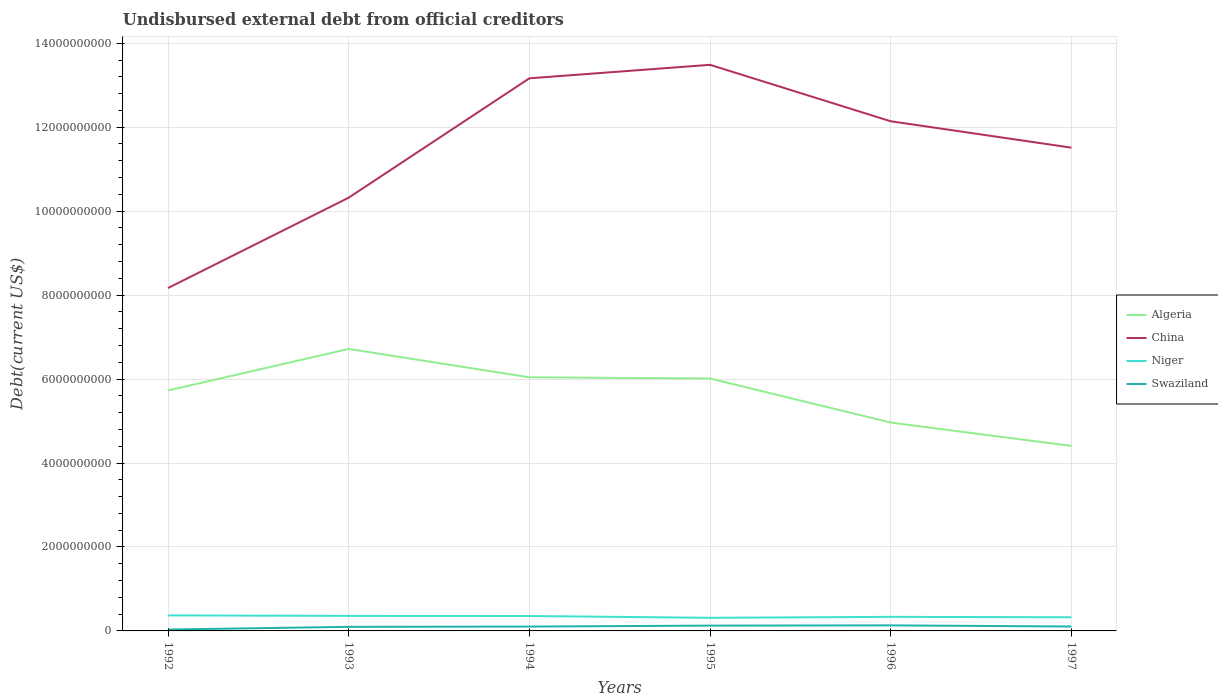How many different coloured lines are there?
Your answer should be compact. 4. Is the number of lines equal to the number of legend labels?
Offer a terse response. Yes. Across all years, what is the maximum total debt in Niger?
Offer a terse response. 3.13e+08. What is the total total debt in Algeria in the graph?
Provide a succinct answer. 2.31e+09. What is the difference between the highest and the second highest total debt in Algeria?
Keep it short and to the point. 2.31e+09. How many years are there in the graph?
Your answer should be compact. 6. Are the values on the major ticks of Y-axis written in scientific E-notation?
Keep it short and to the point. No. How many legend labels are there?
Provide a short and direct response. 4. How are the legend labels stacked?
Ensure brevity in your answer.  Vertical. What is the title of the graph?
Offer a very short reply. Undisbursed external debt from official creditors. Does "East Asia (all income levels)" appear as one of the legend labels in the graph?
Your answer should be compact. No. What is the label or title of the X-axis?
Give a very brief answer. Years. What is the label or title of the Y-axis?
Your response must be concise. Debt(current US$). What is the Debt(current US$) in Algeria in 1992?
Keep it short and to the point. 5.73e+09. What is the Debt(current US$) of China in 1992?
Your answer should be compact. 8.17e+09. What is the Debt(current US$) in Niger in 1992?
Give a very brief answer. 3.70e+08. What is the Debt(current US$) of Swaziland in 1992?
Offer a terse response. 3.31e+07. What is the Debt(current US$) of Algeria in 1993?
Keep it short and to the point. 6.72e+09. What is the Debt(current US$) in China in 1993?
Make the answer very short. 1.03e+1. What is the Debt(current US$) of Niger in 1993?
Provide a short and direct response. 3.58e+08. What is the Debt(current US$) of Swaziland in 1993?
Give a very brief answer. 9.72e+07. What is the Debt(current US$) in Algeria in 1994?
Keep it short and to the point. 6.04e+09. What is the Debt(current US$) of China in 1994?
Ensure brevity in your answer.  1.32e+1. What is the Debt(current US$) of Niger in 1994?
Your response must be concise. 3.55e+08. What is the Debt(current US$) of Swaziland in 1994?
Your answer should be very brief. 1.04e+08. What is the Debt(current US$) of Algeria in 1995?
Your answer should be compact. 6.01e+09. What is the Debt(current US$) of China in 1995?
Your answer should be compact. 1.35e+1. What is the Debt(current US$) of Niger in 1995?
Your answer should be compact. 3.13e+08. What is the Debt(current US$) of Swaziland in 1995?
Offer a terse response. 1.27e+08. What is the Debt(current US$) of Algeria in 1996?
Keep it short and to the point. 4.96e+09. What is the Debt(current US$) of China in 1996?
Offer a terse response. 1.21e+1. What is the Debt(current US$) in Niger in 1996?
Your answer should be very brief. 3.35e+08. What is the Debt(current US$) in Swaziland in 1996?
Provide a succinct answer. 1.32e+08. What is the Debt(current US$) of Algeria in 1997?
Your answer should be very brief. 4.41e+09. What is the Debt(current US$) of China in 1997?
Your answer should be compact. 1.15e+1. What is the Debt(current US$) in Niger in 1997?
Keep it short and to the point. 3.25e+08. What is the Debt(current US$) in Swaziland in 1997?
Your answer should be compact. 1.05e+08. Across all years, what is the maximum Debt(current US$) of Algeria?
Give a very brief answer. 6.72e+09. Across all years, what is the maximum Debt(current US$) of China?
Provide a short and direct response. 1.35e+1. Across all years, what is the maximum Debt(current US$) of Niger?
Provide a short and direct response. 3.70e+08. Across all years, what is the maximum Debt(current US$) of Swaziland?
Provide a succinct answer. 1.32e+08. Across all years, what is the minimum Debt(current US$) of Algeria?
Offer a terse response. 4.41e+09. Across all years, what is the minimum Debt(current US$) in China?
Provide a succinct answer. 8.17e+09. Across all years, what is the minimum Debt(current US$) in Niger?
Ensure brevity in your answer.  3.13e+08. Across all years, what is the minimum Debt(current US$) of Swaziland?
Your response must be concise. 3.31e+07. What is the total Debt(current US$) of Algeria in the graph?
Make the answer very short. 3.39e+1. What is the total Debt(current US$) in China in the graph?
Keep it short and to the point. 6.88e+1. What is the total Debt(current US$) in Niger in the graph?
Keep it short and to the point. 2.06e+09. What is the total Debt(current US$) in Swaziland in the graph?
Offer a terse response. 5.98e+08. What is the difference between the Debt(current US$) in Algeria in 1992 and that in 1993?
Give a very brief answer. -9.90e+08. What is the difference between the Debt(current US$) of China in 1992 and that in 1993?
Ensure brevity in your answer.  -2.15e+09. What is the difference between the Debt(current US$) in Niger in 1992 and that in 1993?
Your answer should be compact. 1.20e+07. What is the difference between the Debt(current US$) in Swaziland in 1992 and that in 1993?
Your answer should be compact. -6.41e+07. What is the difference between the Debt(current US$) of Algeria in 1992 and that in 1994?
Give a very brief answer. -3.14e+08. What is the difference between the Debt(current US$) in China in 1992 and that in 1994?
Your answer should be very brief. -5.00e+09. What is the difference between the Debt(current US$) of Niger in 1992 and that in 1994?
Your response must be concise. 1.50e+07. What is the difference between the Debt(current US$) of Swaziland in 1992 and that in 1994?
Keep it short and to the point. -7.07e+07. What is the difference between the Debt(current US$) of Algeria in 1992 and that in 1995?
Provide a succinct answer. -2.85e+08. What is the difference between the Debt(current US$) of China in 1992 and that in 1995?
Make the answer very short. -5.32e+09. What is the difference between the Debt(current US$) of Niger in 1992 and that in 1995?
Provide a succinct answer. 5.73e+07. What is the difference between the Debt(current US$) in Swaziland in 1992 and that in 1995?
Offer a terse response. -9.35e+07. What is the difference between the Debt(current US$) of Algeria in 1992 and that in 1996?
Ensure brevity in your answer.  7.64e+08. What is the difference between the Debt(current US$) of China in 1992 and that in 1996?
Provide a succinct answer. -3.97e+09. What is the difference between the Debt(current US$) in Niger in 1992 and that in 1996?
Your answer should be compact. 3.53e+07. What is the difference between the Debt(current US$) of Swaziland in 1992 and that in 1996?
Ensure brevity in your answer.  -9.93e+07. What is the difference between the Debt(current US$) in Algeria in 1992 and that in 1997?
Keep it short and to the point. 1.32e+09. What is the difference between the Debt(current US$) in China in 1992 and that in 1997?
Give a very brief answer. -3.34e+09. What is the difference between the Debt(current US$) of Niger in 1992 and that in 1997?
Make the answer very short. 4.50e+07. What is the difference between the Debt(current US$) in Swaziland in 1992 and that in 1997?
Provide a short and direct response. -7.18e+07. What is the difference between the Debt(current US$) of Algeria in 1993 and that in 1994?
Your response must be concise. 6.76e+08. What is the difference between the Debt(current US$) in China in 1993 and that in 1994?
Your response must be concise. -2.84e+09. What is the difference between the Debt(current US$) of Niger in 1993 and that in 1994?
Offer a terse response. 3.01e+06. What is the difference between the Debt(current US$) in Swaziland in 1993 and that in 1994?
Your response must be concise. -6.55e+06. What is the difference between the Debt(current US$) in Algeria in 1993 and that in 1995?
Ensure brevity in your answer.  7.04e+08. What is the difference between the Debt(current US$) in China in 1993 and that in 1995?
Ensure brevity in your answer.  -3.16e+09. What is the difference between the Debt(current US$) in Niger in 1993 and that in 1995?
Make the answer very short. 4.54e+07. What is the difference between the Debt(current US$) of Swaziland in 1993 and that in 1995?
Offer a very short reply. -2.94e+07. What is the difference between the Debt(current US$) of Algeria in 1993 and that in 1996?
Give a very brief answer. 1.75e+09. What is the difference between the Debt(current US$) of China in 1993 and that in 1996?
Ensure brevity in your answer.  -1.82e+09. What is the difference between the Debt(current US$) of Niger in 1993 and that in 1996?
Provide a succinct answer. 2.34e+07. What is the difference between the Debt(current US$) in Swaziland in 1993 and that in 1996?
Provide a short and direct response. -3.51e+07. What is the difference between the Debt(current US$) of Algeria in 1993 and that in 1997?
Provide a short and direct response. 2.31e+09. What is the difference between the Debt(current US$) in China in 1993 and that in 1997?
Your answer should be compact. -1.19e+09. What is the difference between the Debt(current US$) of Niger in 1993 and that in 1997?
Offer a very short reply. 3.31e+07. What is the difference between the Debt(current US$) in Swaziland in 1993 and that in 1997?
Offer a very short reply. -7.65e+06. What is the difference between the Debt(current US$) in Algeria in 1994 and that in 1995?
Give a very brief answer. 2.85e+07. What is the difference between the Debt(current US$) in China in 1994 and that in 1995?
Keep it short and to the point. -3.22e+08. What is the difference between the Debt(current US$) of Niger in 1994 and that in 1995?
Your answer should be compact. 4.24e+07. What is the difference between the Debt(current US$) of Swaziland in 1994 and that in 1995?
Your answer should be very brief. -2.28e+07. What is the difference between the Debt(current US$) of Algeria in 1994 and that in 1996?
Ensure brevity in your answer.  1.08e+09. What is the difference between the Debt(current US$) in China in 1994 and that in 1996?
Offer a very short reply. 1.02e+09. What is the difference between the Debt(current US$) in Niger in 1994 and that in 1996?
Keep it short and to the point. 2.03e+07. What is the difference between the Debt(current US$) in Swaziland in 1994 and that in 1996?
Make the answer very short. -2.86e+07. What is the difference between the Debt(current US$) of Algeria in 1994 and that in 1997?
Offer a very short reply. 1.63e+09. What is the difference between the Debt(current US$) in China in 1994 and that in 1997?
Offer a terse response. 1.65e+09. What is the difference between the Debt(current US$) of Niger in 1994 and that in 1997?
Make the answer very short. 3.01e+07. What is the difference between the Debt(current US$) of Swaziland in 1994 and that in 1997?
Ensure brevity in your answer.  -1.10e+06. What is the difference between the Debt(current US$) in Algeria in 1995 and that in 1996?
Ensure brevity in your answer.  1.05e+09. What is the difference between the Debt(current US$) in China in 1995 and that in 1996?
Your response must be concise. 1.34e+09. What is the difference between the Debt(current US$) of Niger in 1995 and that in 1996?
Ensure brevity in your answer.  -2.20e+07. What is the difference between the Debt(current US$) in Swaziland in 1995 and that in 1996?
Give a very brief answer. -5.76e+06. What is the difference between the Debt(current US$) of Algeria in 1995 and that in 1997?
Ensure brevity in your answer.  1.61e+09. What is the difference between the Debt(current US$) of China in 1995 and that in 1997?
Keep it short and to the point. 1.97e+09. What is the difference between the Debt(current US$) in Niger in 1995 and that in 1997?
Give a very brief answer. -1.23e+07. What is the difference between the Debt(current US$) in Swaziland in 1995 and that in 1997?
Make the answer very short. 2.17e+07. What is the difference between the Debt(current US$) in Algeria in 1996 and that in 1997?
Your answer should be very brief. 5.57e+08. What is the difference between the Debt(current US$) in China in 1996 and that in 1997?
Offer a terse response. 6.29e+08. What is the difference between the Debt(current US$) in Niger in 1996 and that in 1997?
Offer a terse response. 9.73e+06. What is the difference between the Debt(current US$) of Swaziland in 1996 and that in 1997?
Your answer should be very brief. 2.75e+07. What is the difference between the Debt(current US$) of Algeria in 1992 and the Debt(current US$) of China in 1993?
Offer a terse response. -4.59e+09. What is the difference between the Debt(current US$) of Algeria in 1992 and the Debt(current US$) of Niger in 1993?
Keep it short and to the point. 5.37e+09. What is the difference between the Debt(current US$) of Algeria in 1992 and the Debt(current US$) of Swaziland in 1993?
Your response must be concise. 5.63e+09. What is the difference between the Debt(current US$) in China in 1992 and the Debt(current US$) in Niger in 1993?
Provide a short and direct response. 7.81e+09. What is the difference between the Debt(current US$) in China in 1992 and the Debt(current US$) in Swaziland in 1993?
Your answer should be very brief. 8.07e+09. What is the difference between the Debt(current US$) of Niger in 1992 and the Debt(current US$) of Swaziland in 1993?
Give a very brief answer. 2.73e+08. What is the difference between the Debt(current US$) of Algeria in 1992 and the Debt(current US$) of China in 1994?
Provide a short and direct response. -7.44e+09. What is the difference between the Debt(current US$) in Algeria in 1992 and the Debt(current US$) in Niger in 1994?
Give a very brief answer. 5.37e+09. What is the difference between the Debt(current US$) of Algeria in 1992 and the Debt(current US$) of Swaziland in 1994?
Your answer should be compact. 5.62e+09. What is the difference between the Debt(current US$) of China in 1992 and the Debt(current US$) of Niger in 1994?
Your response must be concise. 7.81e+09. What is the difference between the Debt(current US$) in China in 1992 and the Debt(current US$) in Swaziland in 1994?
Offer a very short reply. 8.06e+09. What is the difference between the Debt(current US$) in Niger in 1992 and the Debt(current US$) in Swaziland in 1994?
Make the answer very short. 2.66e+08. What is the difference between the Debt(current US$) in Algeria in 1992 and the Debt(current US$) in China in 1995?
Ensure brevity in your answer.  -7.76e+09. What is the difference between the Debt(current US$) of Algeria in 1992 and the Debt(current US$) of Niger in 1995?
Your response must be concise. 5.41e+09. What is the difference between the Debt(current US$) in Algeria in 1992 and the Debt(current US$) in Swaziland in 1995?
Make the answer very short. 5.60e+09. What is the difference between the Debt(current US$) in China in 1992 and the Debt(current US$) in Niger in 1995?
Your answer should be very brief. 7.86e+09. What is the difference between the Debt(current US$) in China in 1992 and the Debt(current US$) in Swaziland in 1995?
Give a very brief answer. 8.04e+09. What is the difference between the Debt(current US$) in Niger in 1992 and the Debt(current US$) in Swaziland in 1995?
Offer a very short reply. 2.44e+08. What is the difference between the Debt(current US$) of Algeria in 1992 and the Debt(current US$) of China in 1996?
Provide a short and direct response. -6.41e+09. What is the difference between the Debt(current US$) in Algeria in 1992 and the Debt(current US$) in Niger in 1996?
Offer a very short reply. 5.39e+09. What is the difference between the Debt(current US$) of Algeria in 1992 and the Debt(current US$) of Swaziland in 1996?
Offer a terse response. 5.60e+09. What is the difference between the Debt(current US$) in China in 1992 and the Debt(current US$) in Niger in 1996?
Give a very brief answer. 7.83e+09. What is the difference between the Debt(current US$) of China in 1992 and the Debt(current US$) of Swaziland in 1996?
Ensure brevity in your answer.  8.04e+09. What is the difference between the Debt(current US$) of Niger in 1992 and the Debt(current US$) of Swaziland in 1996?
Provide a succinct answer. 2.38e+08. What is the difference between the Debt(current US$) of Algeria in 1992 and the Debt(current US$) of China in 1997?
Provide a short and direct response. -5.78e+09. What is the difference between the Debt(current US$) in Algeria in 1992 and the Debt(current US$) in Niger in 1997?
Provide a succinct answer. 5.40e+09. What is the difference between the Debt(current US$) of Algeria in 1992 and the Debt(current US$) of Swaziland in 1997?
Your answer should be very brief. 5.62e+09. What is the difference between the Debt(current US$) in China in 1992 and the Debt(current US$) in Niger in 1997?
Offer a very short reply. 7.84e+09. What is the difference between the Debt(current US$) in China in 1992 and the Debt(current US$) in Swaziland in 1997?
Keep it short and to the point. 8.06e+09. What is the difference between the Debt(current US$) in Niger in 1992 and the Debt(current US$) in Swaziland in 1997?
Your answer should be very brief. 2.65e+08. What is the difference between the Debt(current US$) of Algeria in 1993 and the Debt(current US$) of China in 1994?
Offer a very short reply. -6.45e+09. What is the difference between the Debt(current US$) in Algeria in 1993 and the Debt(current US$) in Niger in 1994?
Provide a succinct answer. 6.36e+09. What is the difference between the Debt(current US$) of Algeria in 1993 and the Debt(current US$) of Swaziland in 1994?
Ensure brevity in your answer.  6.61e+09. What is the difference between the Debt(current US$) of China in 1993 and the Debt(current US$) of Niger in 1994?
Keep it short and to the point. 9.97e+09. What is the difference between the Debt(current US$) of China in 1993 and the Debt(current US$) of Swaziland in 1994?
Provide a short and direct response. 1.02e+1. What is the difference between the Debt(current US$) in Niger in 1993 and the Debt(current US$) in Swaziland in 1994?
Make the answer very short. 2.54e+08. What is the difference between the Debt(current US$) in Algeria in 1993 and the Debt(current US$) in China in 1995?
Your response must be concise. -6.77e+09. What is the difference between the Debt(current US$) in Algeria in 1993 and the Debt(current US$) in Niger in 1995?
Provide a succinct answer. 6.40e+09. What is the difference between the Debt(current US$) in Algeria in 1993 and the Debt(current US$) in Swaziland in 1995?
Keep it short and to the point. 6.59e+09. What is the difference between the Debt(current US$) in China in 1993 and the Debt(current US$) in Niger in 1995?
Ensure brevity in your answer.  1.00e+1. What is the difference between the Debt(current US$) in China in 1993 and the Debt(current US$) in Swaziland in 1995?
Your answer should be compact. 1.02e+1. What is the difference between the Debt(current US$) of Niger in 1993 and the Debt(current US$) of Swaziland in 1995?
Provide a succinct answer. 2.32e+08. What is the difference between the Debt(current US$) in Algeria in 1993 and the Debt(current US$) in China in 1996?
Make the answer very short. -5.42e+09. What is the difference between the Debt(current US$) in Algeria in 1993 and the Debt(current US$) in Niger in 1996?
Provide a short and direct response. 6.38e+09. What is the difference between the Debt(current US$) in Algeria in 1993 and the Debt(current US$) in Swaziland in 1996?
Keep it short and to the point. 6.58e+09. What is the difference between the Debt(current US$) of China in 1993 and the Debt(current US$) of Niger in 1996?
Provide a succinct answer. 9.99e+09. What is the difference between the Debt(current US$) of China in 1993 and the Debt(current US$) of Swaziland in 1996?
Give a very brief answer. 1.02e+1. What is the difference between the Debt(current US$) of Niger in 1993 and the Debt(current US$) of Swaziland in 1996?
Provide a succinct answer. 2.26e+08. What is the difference between the Debt(current US$) of Algeria in 1993 and the Debt(current US$) of China in 1997?
Your response must be concise. -4.79e+09. What is the difference between the Debt(current US$) of Algeria in 1993 and the Debt(current US$) of Niger in 1997?
Give a very brief answer. 6.39e+09. What is the difference between the Debt(current US$) of Algeria in 1993 and the Debt(current US$) of Swaziland in 1997?
Offer a very short reply. 6.61e+09. What is the difference between the Debt(current US$) in China in 1993 and the Debt(current US$) in Niger in 1997?
Offer a very short reply. 1.00e+1. What is the difference between the Debt(current US$) in China in 1993 and the Debt(current US$) in Swaziland in 1997?
Make the answer very short. 1.02e+1. What is the difference between the Debt(current US$) in Niger in 1993 and the Debt(current US$) in Swaziland in 1997?
Keep it short and to the point. 2.53e+08. What is the difference between the Debt(current US$) of Algeria in 1994 and the Debt(current US$) of China in 1995?
Make the answer very short. -7.44e+09. What is the difference between the Debt(current US$) in Algeria in 1994 and the Debt(current US$) in Niger in 1995?
Your response must be concise. 5.73e+09. What is the difference between the Debt(current US$) in Algeria in 1994 and the Debt(current US$) in Swaziland in 1995?
Your answer should be compact. 5.91e+09. What is the difference between the Debt(current US$) in China in 1994 and the Debt(current US$) in Niger in 1995?
Your answer should be very brief. 1.29e+1. What is the difference between the Debt(current US$) in China in 1994 and the Debt(current US$) in Swaziland in 1995?
Your response must be concise. 1.30e+1. What is the difference between the Debt(current US$) of Niger in 1994 and the Debt(current US$) of Swaziland in 1995?
Your answer should be very brief. 2.29e+08. What is the difference between the Debt(current US$) in Algeria in 1994 and the Debt(current US$) in China in 1996?
Offer a very short reply. -6.10e+09. What is the difference between the Debt(current US$) of Algeria in 1994 and the Debt(current US$) of Niger in 1996?
Provide a succinct answer. 5.71e+09. What is the difference between the Debt(current US$) of Algeria in 1994 and the Debt(current US$) of Swaziland in 1996?
Keep it short and to the point. 5.91e+09. What is the difference between the Debt(current US$) in China in 1994 and the Debt(current US$) in Niger in 1996?
Make the answer very short. 1.28e+1. What is the difference between the Debt(current US$) of China in 1994 and the Debt(current US$) of Swaziland in 1996?
Offer a very short reply. 1.30e+1. What is the difference between the Debt(current US$) in Niger in 1994 and the Debt(current US$) in Swaziland in 1996?
Provide a short and direct response. 2.23e+08. What is the difference between the Debt(current US$) of Algeria in 1994 and the Debt(current US$) of China in 1997?
Your answer should be very brief. -5.47e+09. What is the difference between the Debt(current US$) in Algeria in 1994 and the Debt(current US$) in Niger in 1997?
Offer a very short reply. 5.72e+09. What is the difference between the Debt(current US$) in Algeria in 1994 and the Debt(current US$) in Swaziland in 1997?
Provide a short and direct response. 5.94e+09. What is the difference between the Debt(current US$) in China in 1994 and the Debt(current US$) in Niger in 1997?
Make the answer very short. 1.28e+1. What is the difference between the Debt(current US$) in China in 1994 and the Debt(current US$) in Swaziland in 1997?
Provide a short and direct response. 1.31e+1. What is the difference between the Debt(current US$) in Niger in 1994 and the Debt(current US$) in Swaziland in 1997?
Provide a succinct answer. 2.50e+08. What is the difference between the Debt(current US$) in Algeria in 1995 and the Debt(current US$) in China in 1996?
Your answer should be compact. -6.13e+09. What is the difference between the Debt(current US$) of Algeria in 1995 and the Debt(current US$) of Niger in 1996?
Provide a succinct answer. 5.68e+09. What is the difference between the Debt(current US$) of Algeria in 1995 and the Debt(current US$) of Swaziland in 1996?
Keep it short and to the point. 5.88e+09. What is the difference between the Debt(current US$) in China in 1995 and the Debt(current US$) in Niger in 1996?
Your answer should be very brief. 1.32e+1. What is the difference between the Debt(current US$) of China in 1995 and the Debt(current US$) of Swaziland in 1996?
Keep it short and to the point. 1.34e+1. What is the difference between the Debt(current US$) of Niger in 1995 and the Debt(current US$) of Swaziland in 1996?
Offer a terse response. 1.80e+08. What is the difference between the Debt(current US$) in Algeria in 1995 and the Debt(current US$) in China in 1997?
Provide a succinct answer. -5.50e+09. What is the difference between the Debt(current US$) in Algeria in 1995 and the Debt(current US$) in Niger in 1997?
Offer a terse response. 5.69e+09. What is the difference between the Debt(current US$) in Algeria in 1995 and the Debt(current US$) in Swaziland in 1997?
Provide a succinct answer. 5.91e+09. What is the difference between the Debt(current US$) in China in 1995 and the Debt(current US$) in Niger in 1997?
Offer a terse response. 1.32e+1. What is the difference between the Debt(current US$) of China in 1995 and the Debt(current US$) of Swaziland in 1997?
Your response must be concise. 1.34e+1. What is the difference between the Debt(current US$) of Niger in 1995 and the Debt(current US$) of Swaziland in 1997?
Give a very brief answer. 2.08e+08. What is the difference between the Debt(current US$) in Algeria in 1996 and the Debt(current US$) in China in 1997?
Provide a succinct answer. -6.55e+09. What is the difference between the Debt(current US$) in Algeria in 1996 and the Debt(current US$) in Niger in 1997?
Your response must be concise. 4.64e+09. What is the difference between the Debt(current US$) in Algeria in 1996 and the Debt(current US$) in Swaziland in 1997?
Keep it short and to the point. 4.86e+09. What is the difference between the Debt(current US$) of China in 1996 and the Debt(current US$) of Niger in 1997?
Your response must be concise. 1.18e+1. What is the difference between the Debt(current US$) in China in 1996 and the Debt(current US$) in Swaziland in 1997?
Offer a very short reply. 1.20e+1. What is the difference between the Debt(current US$) in Niger in 1996 and the Debt(current US$) in Swaziland in 1997?
Give a very brief answer. 2.30e+08. What is the average Debt(current US$) of Algeria per year?
Ensure brevity in your answer.  5.65e+09. What is the average Debt(current US$) of China per year?
Provide a succinct answer. 1.15e+1. What is the average Debt(current US$) of Niger per year?
Provide a succinct answer. 3.43e+08. What is the average Debt(current US$) in Swaziland per year?
Your response must be concise. 9.97e+07. In the year 1992, what is the difference between the Debt(current US$) in Algeria and Debt(current US$) in China?
Provide a succinct answer. -2.44e+09. In the year 1992, what is the difference between the Debt(current US$) in Algeria and Debt(current US$) in Niger?
Keep it short and to the point. 5.36e+09. In the year 1992, what is the difference between the Debt(current US$) of Algeria and Debt(current US$) of Swaziland?
Your response must be concise. 5.69e+09. In the year 1992, what is the difference between the Debt(current US$) of China and Debt(current US$) of Niger?
Provide a succinct answer. 7.80e+09. In the year 1992, what is the difference between the Debt(current US$) in China and Debt(current US$) in Swaziland?
Make the answer very short. 8.14e+09. In the year 1992, what is the difference between the Debt(current US$) of Niger and Debt(current US$) of Swaziland?
Offer a very short reply. 3.37e+08. In the year 1993, what is the difference between the Debt(current US$) in Algeria and Debt(current US$) in China?
Offer a very short reply. -3.60e+09. In the year 1993, what is the difference between the Debt(current US$) in Algeria and Debt(current US$) in Niger?
Offer a terse response. 6.36e+09. In the year 1993, what is the difference between the Debt(current US$) of Algeria and Debt(current US$) of Swaziland?
Make the answer very short. 6.62e+09. In the year 1993, what is the difference between the Debt(current US$) of China and Debt(current US$) of Niger?
Offer a terse response. 9.96e+09. In the year 1993, what is the difference between the Debt(current US$) of China and Debt(current US$) of Swaziland?
Ensure brevity in your answer.  1.02e+1. In the year 1993, what is the difference between the Debt(current US$) in Niger and Debt(current US$) in Swaziland?
Give a very brief answer. 2.61e+08. In the year 1994, what is the difference between the Debt(current US$) of Algeria and Debt(current US$) of China?
Ensure brevity in your answer.  -7.12e+09. In the year 1994, what is the difference between the Debt(current US$) of Algeria and Debt(current US$) of Niger?
Keep it short and to the point. 5.69e+09. In the year 1994, what is the difference between the Debt(current US$) in Algeria and Debt(current US$) in Swaziland?
Keep it short and to the point. 5.94e+09. In the year 1994, what is the difference between the Debt(current US$) in China and Debt(current US$) in Niger?
Offer a terse response. 1.28e+1. In the year 1994, what is the difference between the Debt(current US$) in China and Debt(current US$) in Swaziland?
Your answer should be compact. 1.31e+1. In the year 1994, what is the difference between the Debt(current US$) in Niger and Debt(current US$) in Swaziland?
Offer a terse response. 2.51e+08. In the year 1995, what is the difference between the Debt(current US$) of Algeria and Debt(current US$) of China?
Keep it short and to the point. -7.47e+09. In the year 1995, what is the difference between the Debt(current US$) in Algeria and Debt(current US$) in Niger?
Keep it short and to the point. 5.70e+09. In the year 1995, what is the difference between the Debt(current US$) in Algeria and Debt(current US$) in Swaziland?
Your answer should be compact. 5.89e+09. In the year 1995, what is the difference between the Debt(current US$) of China and Debt(current US$) of Niger?
Make the answer very short. 1.32e+1. In the year 1995, what is the difference between the Debt(current US$) in China and Debt(current US$) in Swaziland?
Give a very brief answer. 1.34e+1. In the year 1995, what is the difference between the Debt(current US$) in Niger and Debt(current US$) in Swaziland?
Keep it short and to the point. 1.86e+08. In the year 1996, what is the difference between the Debt(current US$) of Algeria and Debt(current US$) of China?
Your response must be concise. -7.18e+09. In the year 1996, what is the difference between the Debt(current US$) of Algeria and Debt(current US$) of Niger?
Your answer should be compact. 4.63e+09. In the year 1996, what is the difference between the Debt(current US$) of Algeria and Debt(current US$) of Swaziland?
Ensure brevity in your answer.  4.83e+09. In the year 1996, what is the difference between the Debt(current US$) of China and Debt(current US$) of Niger?
Your response must be concise. 1.18e+1. In the year 1996, what is the difference between the Debt(current US$) of China and Debt(current US$) of Swaziland?
Your answer should be compact. 1.20e+1. In the year 1996, what is the difference between the Debt(current US$) of Niger and Debt(current US$) of Swaziland?
Provide a short and direct response. 2.02e+08. In the year 1997, what is the difference between the Debt(current US$) in Algeria and Debt(current US$) in China?
Offer a very short reply. -7.11e+09. In the year 1997, what is the difference between the Debt(current US$) in Algeria and Debt(current US$) in Niger?
Provide a short and direct response. 4.08e+09. In the year 1997, what is the difference between the Debt(current US$) in Algeria and Debt(current US$) in Swaziland?
Your response must be concise. 4.30e+09. In the year 1997, what is the difference between the Debt(current US$) in China and Debt(current US$) in Niger?
Offer a terse response. 1.12e+1. In the year 1997, what is the difference between the Debt(current US$) of China and Debt(current US$) of Swaziland?
Keep it short and to the point. 1.14e+1. In the year 1997, what is the difference between the Debt(current US$) in Niger and Debt(current US$) in Swaziland?
Your response must be concise. 2.20e+08. What is the ratio of the Debt(current US$) of Algeria in 1992 to that in 1993?
Offer a very short reply. 0.85. What is the ratio of the Debt(current US$) in China in 1992 to that in 1993?
Keep it short and to the point. 0.79. What is the ratio of the Debt(current US$) in Niger in 1992 to that in 1993?
Your response must be concise. 1.03. What is the ratio of the Debt(current US$) in Swaziland in 1992 to that in 1993?
Your answer should be compact. 0.34. What is the ratio of the Debt(current US$) in Algeria in 1992 to that in 1994?
Provide a succinct answer. 0.95. What is the ratio of the Debt(current US$) in China in 1992 to that in 1994?
Ensure brevity in your answer.  0.62. What is the ratio of the Debt(current US$) of Niger in 1992 to that in 1994?
Provide a succinct answer. 1.04. What is the ratio of the Debt(current US$) of Swaziland in 1992 to that in 1994?
Offer a very short reply. 0.32. What is the ratio of the Debt(current US$) in Algeria in 1992 to that in 1995?
Your response must be concise. 0.95. What is the ratio of the Debt(current US$) of China in 1992 to that in 1995?
Your answer should be compact. 0.61. What is the ratio of the Debt(current US$) in Niger in 1992 to that in 1995?
Make the answer very short. 1.18. What is the ratio of the Debt(current US$) of Swaziland in 1992 to that in 1995?
Make the answer very short. 0.26. What is the ratio of the Debt(current US$) of Algeria in 1992 to that in 1996?
Offer a terse response. 1.15. What is the ratio of the Debt(current US$) of China in 1992 to that in 1996?
Your answer should be very brief. 0.67. What is the ratio of the Debt(current US$) in Niger in 1992 to that in 1996?
Provide a succinct answer. 1.11. What is the ratio of the Debt(current US$) in Swaziland in 1992 to that in 1996?
Make the answer very short. 0.25. What is the ratio of the Debt(current US$) in Algeria in 1992 to that in 1997?
Ensure brevity in your answer.  1.3. What is the ratio of the Debt(current US$) in China in 1992 to that in 1997?
Offer a terse response. 0.71. What is the ratio of the Debt(current US$) of Niger in 1992 to that in 1997?
Provide a succinct answer. 1.14. What is the ratio of the Debt(current US$) in Swaziland in 1992 to that in 1997?
Keep it short and to the point. 0.32. What is the ratio of the Debt(current US$) in Algeria in 1993 to that in 1994?
Make the answer very short. 1.11. What is the ratio of the Debt(current US$) in China in 1993 to that in 1994?
Provide a short and direct response. 0.78. What is the ratio of the Debt(current US$) of Niger in 1993 to that in 1994?
Provide a short and direct response. 1.01. What is the ratio of the Debt(current US$) of Swaziland in 1993 to that in 1994?
Make the answer very short. 0.94. What is the ratio of the Debt(current US$) of Algeria in 1993 to that in 1995?
Your answer should be compact. 1.12. What is the ratio of the Debt(current US$) in China in 1993 to that in 1995?
Ensure brevity in your answer.  0.77. What is the ratio of the Debt(current US$) in Niger in 1993 to that in 1995?
Keep it short and to the point. 1.15. What is the ratio of the Debt(current US$) of Swaziland in 1993 to that in 1995?
Your answer should be very brief. 0.77. What is the ratio of the Debt(current US$) of Algeria in 1993 to that in 1996?
Your answer should be very brief. 1.35. What is the ratio of the Debt(current US$) in China in 1993 to that in 1996?
Give a very brief answer. 0.85. What is the ratio of the Debt(current US$) in Niger in 1993 to that in 1996?
Ensure brevity in your answer.  1.07. What is the ratio of the Debt(current US$) in Swaziland in 1993 to that in 1996?
Ensure brevity in your answer.  0.73. What is the ratio of the Debt(current US$) of Algeria in 1993 to that in 1997?
Provide a short and direct response. 1.52. What is the ratio of the Debt(current US$) of China in 1993 to that in 1997?
Your answer should be compact. 0.9. What is the ratio of the Debt(current US$) of Niger in 1993 to that in 1997?
Your answer should be compact. 1.1. What is the ratio of the Debt(current US$) of Swaziland in 1993 to that in 1997?
Your answer should be very brief. 0.93. What is the ratio of the Debt(current US$) of China in 1994 to that in 1995?
Ensure brevity in your answer.  0.98. What is the ratio of the Debt(current US$) in Niger in 1994 to that in 1995?
Make the answer very short. 1.14. What is the ratio of the Debt(current US$) in Swaziland in 1994 to that in 1995?
Provide a succinct answer. 0.82. What is the ratio of the Debt(current US$) of Algeria in 1994 to that in 1996?
Your answer should be very brief. 1.22. What is the ratio of the Debt(current US$) of China in 1994 to that in 1996?
Keep it short and to the point. 1.08. What is the ratio of the Debt(current US$) in Niger in 1994 to that in 1996?
Keep it short and to the point. 1.06. What is the ratio of the Debt(current US$) of Swaziland in 1994 to that in 1996?
Your answer should be compact. 0.78. What is the ratio of the Debt(current US$) in Algeria in 1994 to that in 1997?
Provide a short and direct response. 1.37. What is the ratio of the Debt(current US$) of China in 1994 to that in 1997?
Make the answer very short. 1.14. What is the ratio of the Debt(current US$) in Niger in 1994 to that in 1997?
Provide a succinct answer. 1.09. What is the ratio of the Debt(current US$) of Algeria in 1995 to that in 1996?
Provide a short and direct response. 1.21. What is the ratio of the Debt(current US$) in China in 1995 to that in 1996?
Provide a succinct answer. 1.11. What is the ratio of the Debt(current US$) of Niger in 1995 to that in 1996?
Provide a short and direct response. 0.93. What is the ratio of the Debt(current US$) of Swaziland in 1995 to that in 1996?
Give a very brief answer. 0.96. What is the ratio of the Debt(current US$) of Algeria in 1995 to that in 1997?
Your answer should be very brief. 1.36. What is the ratio of the Debt(current US$) of China in 1995 to that in 1997?
Offer a terse response. 1.17. What is the ratio of the Debt(current US$) of Niger in 1995 to that in 1997?
Your answer should be very brief. 0.96. What is the ratio of the Debt(current US$) of Swaziland in 1995 to that in 1997?
Keep it short and to the point. 1.21. What is the ratio of the Debt(current US$) of Algeria in 1996 to that in 1997?
Provide a succinct answer. 1.13. What is the ratio of the Debt(current US$) in China in 1996 to that in 1997?
Make the answer very short. 1.05. What is the ratio of the Debt(current US$) in Niger in 1996 to that in 1997?
Make the answer very short. 1.03. What is the ratio of the Debt(current US$) of Swaziland in 1996 to that in 1997?
Make the answer very short. 1.26. What is the difference between the highest and the second highest Debt(current US$) of Algeria?
Your answer should be compact. 6.76e+08. What is the difference between the highest and the second highest Debt(current US$) in China?
Keep it short and to the point. 3.22e+08. What is the difference between the highest and the second highest Debt(current US$) of Niger?
Your response must be concise. 1.20e+07. What is the difference between the highest and the second highest Debt(current US$) in Swaziland?
Your answer should be very brief. 5.76e+06. What is the difference between the highest and the lowest Debt(current US$) in Algeria?
Provide a succinct answer. 2.31e+09. What is the difference between the highest and the lowest Debt(current US$) of China?
Make the answer very short. 5.32e+09. What is the difference between the highest and the lowest Debt(current US$) in Niger?
Provide a short and direct response. 5.73e+07. What is the difference between the highest and the lowest Debt(current US$) in Swaziland?
Offer a very short reply. 9.93e+07. 